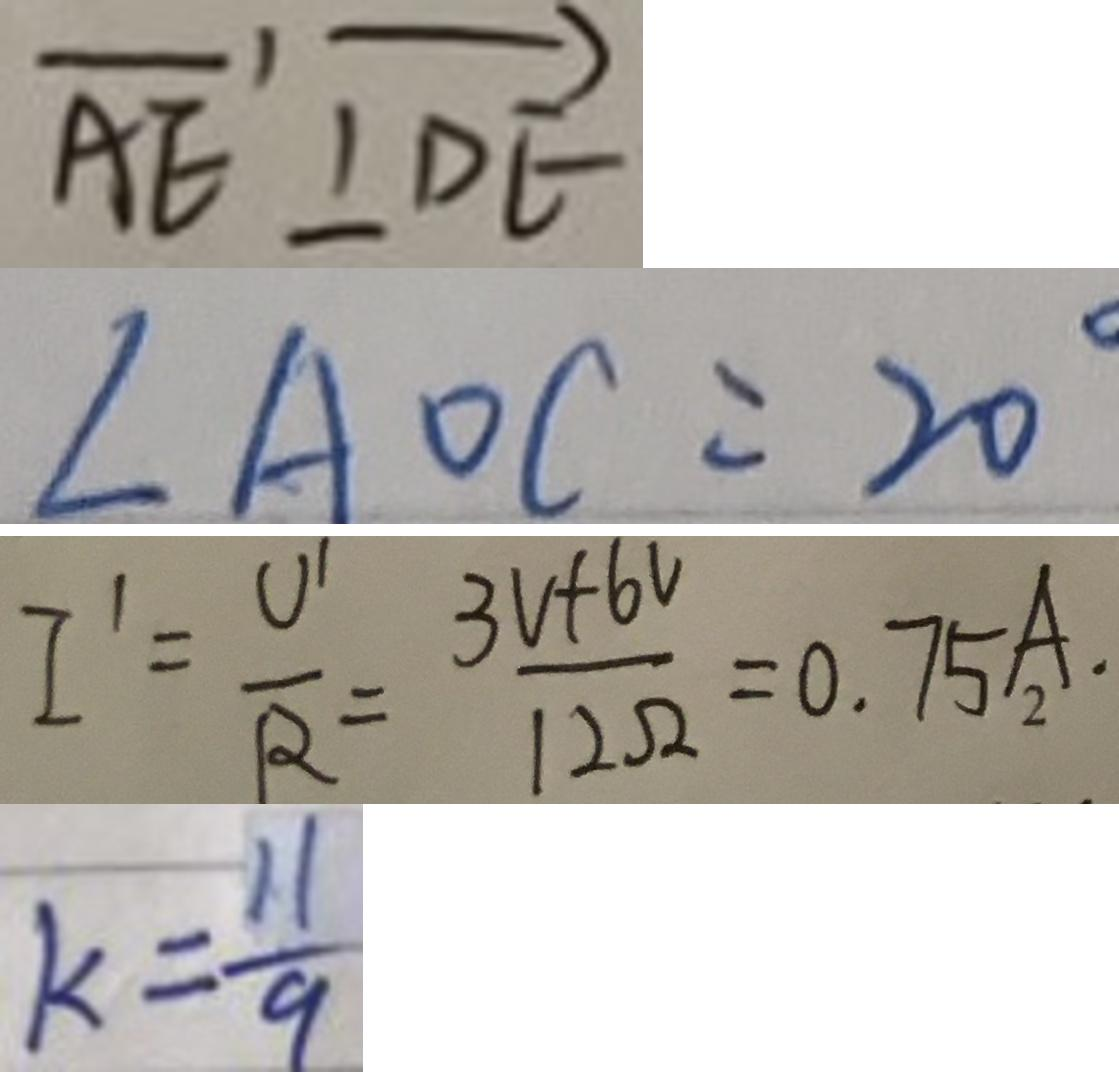Convert formula to latex. <formula><loc_0><loc_0><loc_500><loc_500>\overrightarrow { A E } \bot \overrightarrow { D E } 
 \angle A O C = 2 0 ^ { \circ } 
 I ^ { \prime } = \frac { U ^ { \prime } } { R } = \frac { 3 V + 6 V } { 1 2 \Omega } = 0 . 7 5 A . 
 k = \frac { 1 1 } { 9 }</formula> 